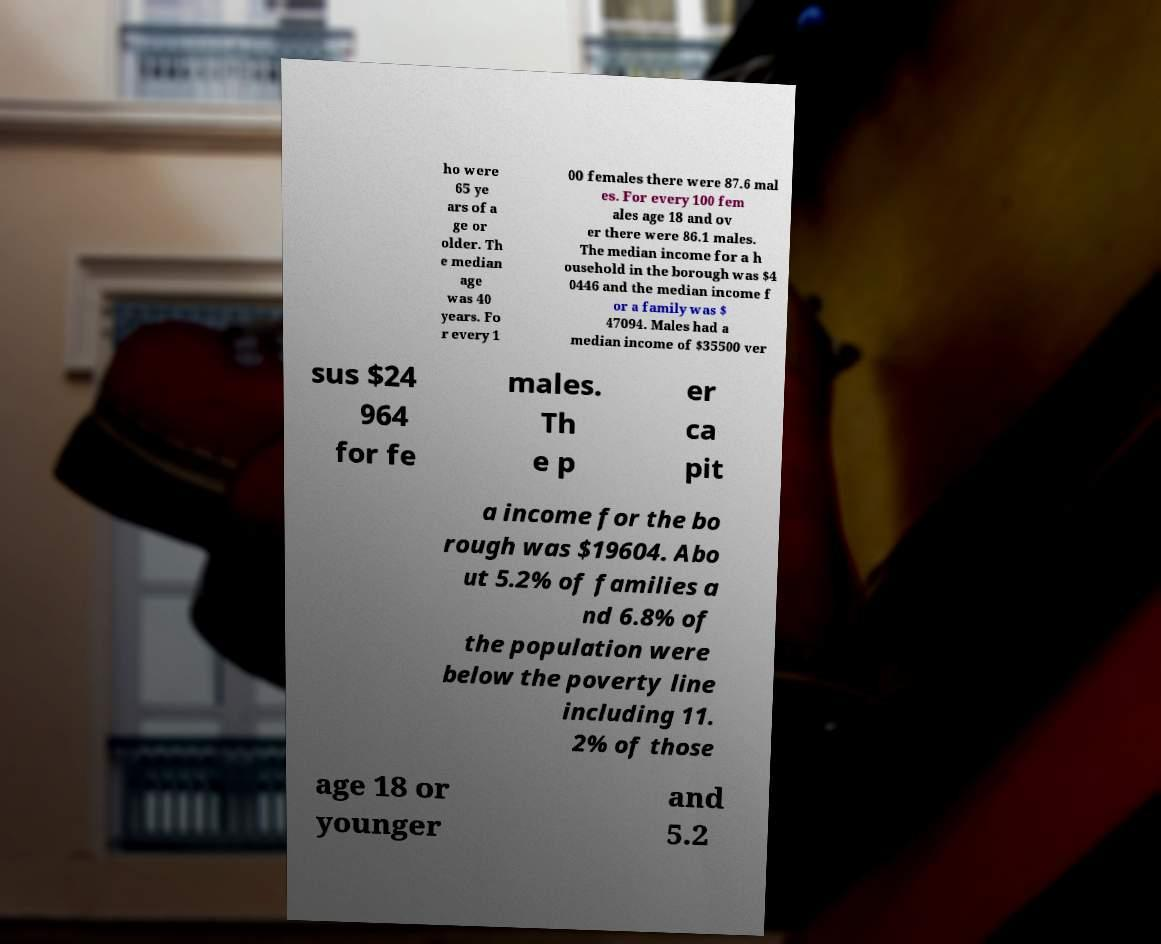What messages or text are displayed in this image? I need them in a readable, typed format. ho were 65 ye ars of a ge or older. Th e median age was 40 years. Fo r every 1 00 females there were 87.6 mal es. For every 100 fem ales age 18 and ov er there were 86.1 males. The median income for a h ousehold in the borough was $4 0446 and the median income f or a family was $ 47094. Males had a median income of $35500 ver sus $24 964 for fe males. Th e p er ca pit a income for the bo rough was $19604. Abo ut 5.2% of families a nd 6.8% of the population were below the poverty line including 11. 2% of those age 18 or younger and 5.2 